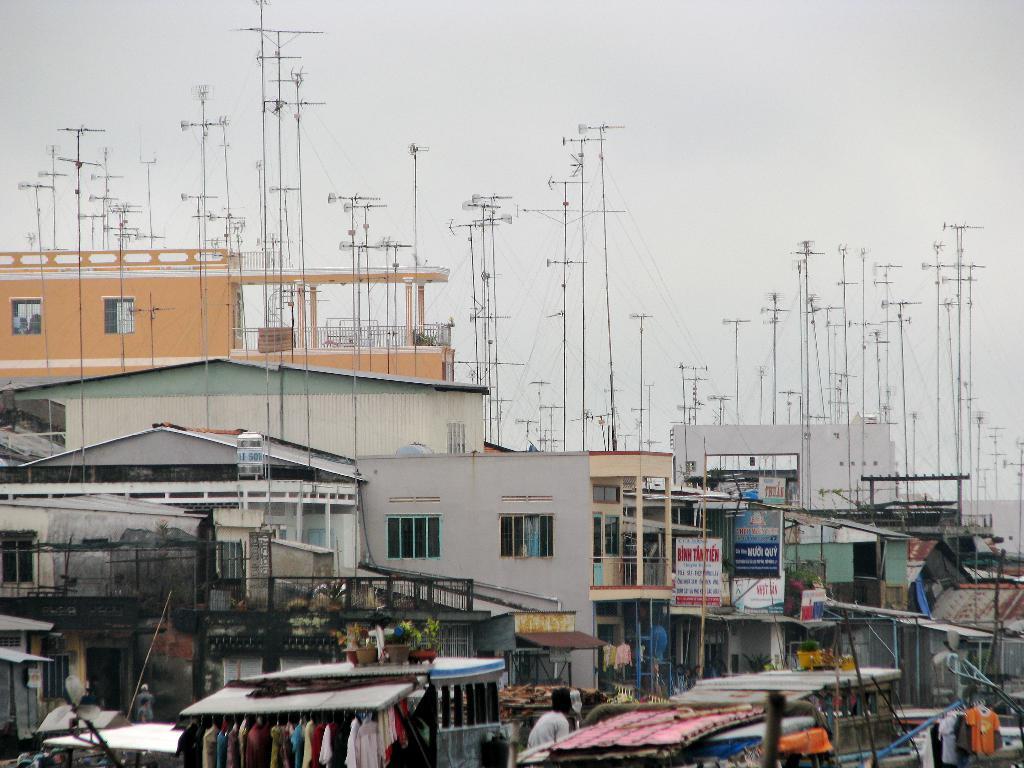Please provide a concise description of this image. There are clothes arranged. In the background, there are buildings, poles, hoardings and there are clouds in the sky. 